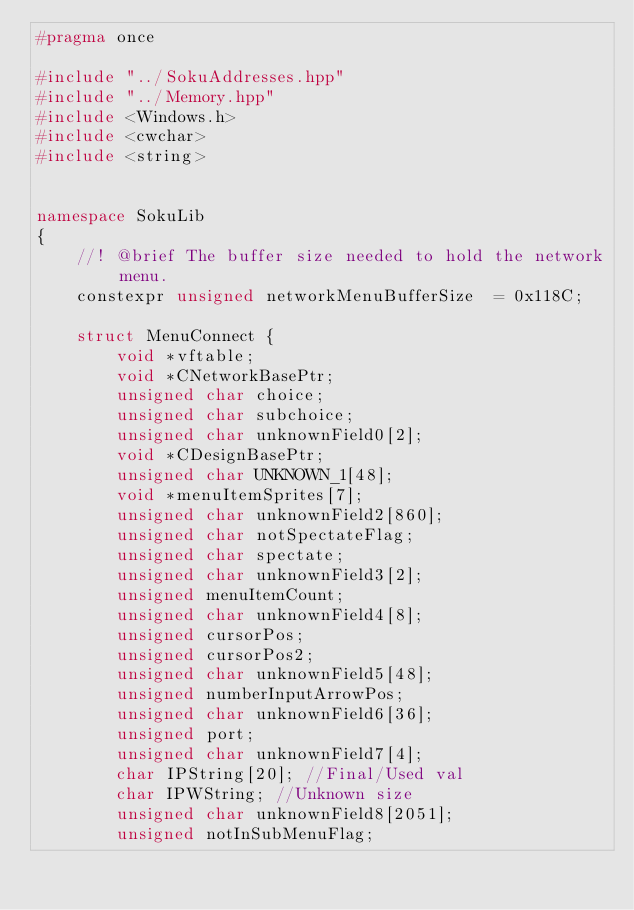<code> <loc_0><loc_0><loc_500><loc_500><_C++_>#pragma once

#include "../SokuAddresses.hpp"
#include "../Memory.hpp"
#include <Windows.h>
#include <cwchar>
#include <string>


namespace SokuLib
{
	//! @brief The buffer size needed to hold the network menu.
	constexpr unsigned networkMenuBufferSize  = 0x118C;

	struct MenuConnect {
		void *vftable;
		void *CNetworkBasePtr;
		unsigned char choice;
		unsigned char subchoice;
		unsigned char unknownField0[2];
		void *CDesignBasePtr;
		unsigned char UNKNOWN_1[48];
		void *menuItemSprites[7];
		unsigned char unknownField2[860];
		unsigned char notSpectateFlag;
		unsigned char spectate;
		unsigned char unknownField3[2];
		unsigned menuItemCount;
		unsigned char unknownField4[8];
		unsigned cursorPos;
		unsigned cursorPos2;
		unsigned char unknownField5[48];
		unsigned numberInputArrowPos;
		unsigned char unknownField6[36];
		unsigned port;
		unsigned char unknownField7[4];
		char IPString[20]; //Final/Used val
		char IPWString; //Unknown size
		unsigned char unknownField8[2051];
		unsigned notInSubMenuFlag;</code> 